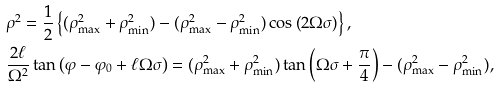Convert formula to latex. <formula><loc_0><loc_0><loc_500><loc_500>& { \rho } ^ { 2 } = \frac { 1 } { 2 } \left \{ ( \rho _ { \max } ^ { 2 } + \rho _ { \min } ^ { 2 } ) - ( \rho _ { \max } ^ { 2 } - \rho _ { \min } ^ { 2 } ) \cos \left ( 2 \Omega \sigma \right ) \right \} , \\ & \frac { 2 \ell } { \Omega ^ { 2 } } \tan \left ( { \varphi } - \varphi _ { 0 } + \ell \Omega \sigma \right ) = ( \rho _ { \max } ^ { 2 } + \rho _ { \min } ^ { 2 } ) \tan \left ( \Omega \sigma + \frac { \pi } { 4 } \right ) - ( \rho _ { \max } ^ { 2 } - \rho _ { \min } ^ { 2 } ) ,</formula> 